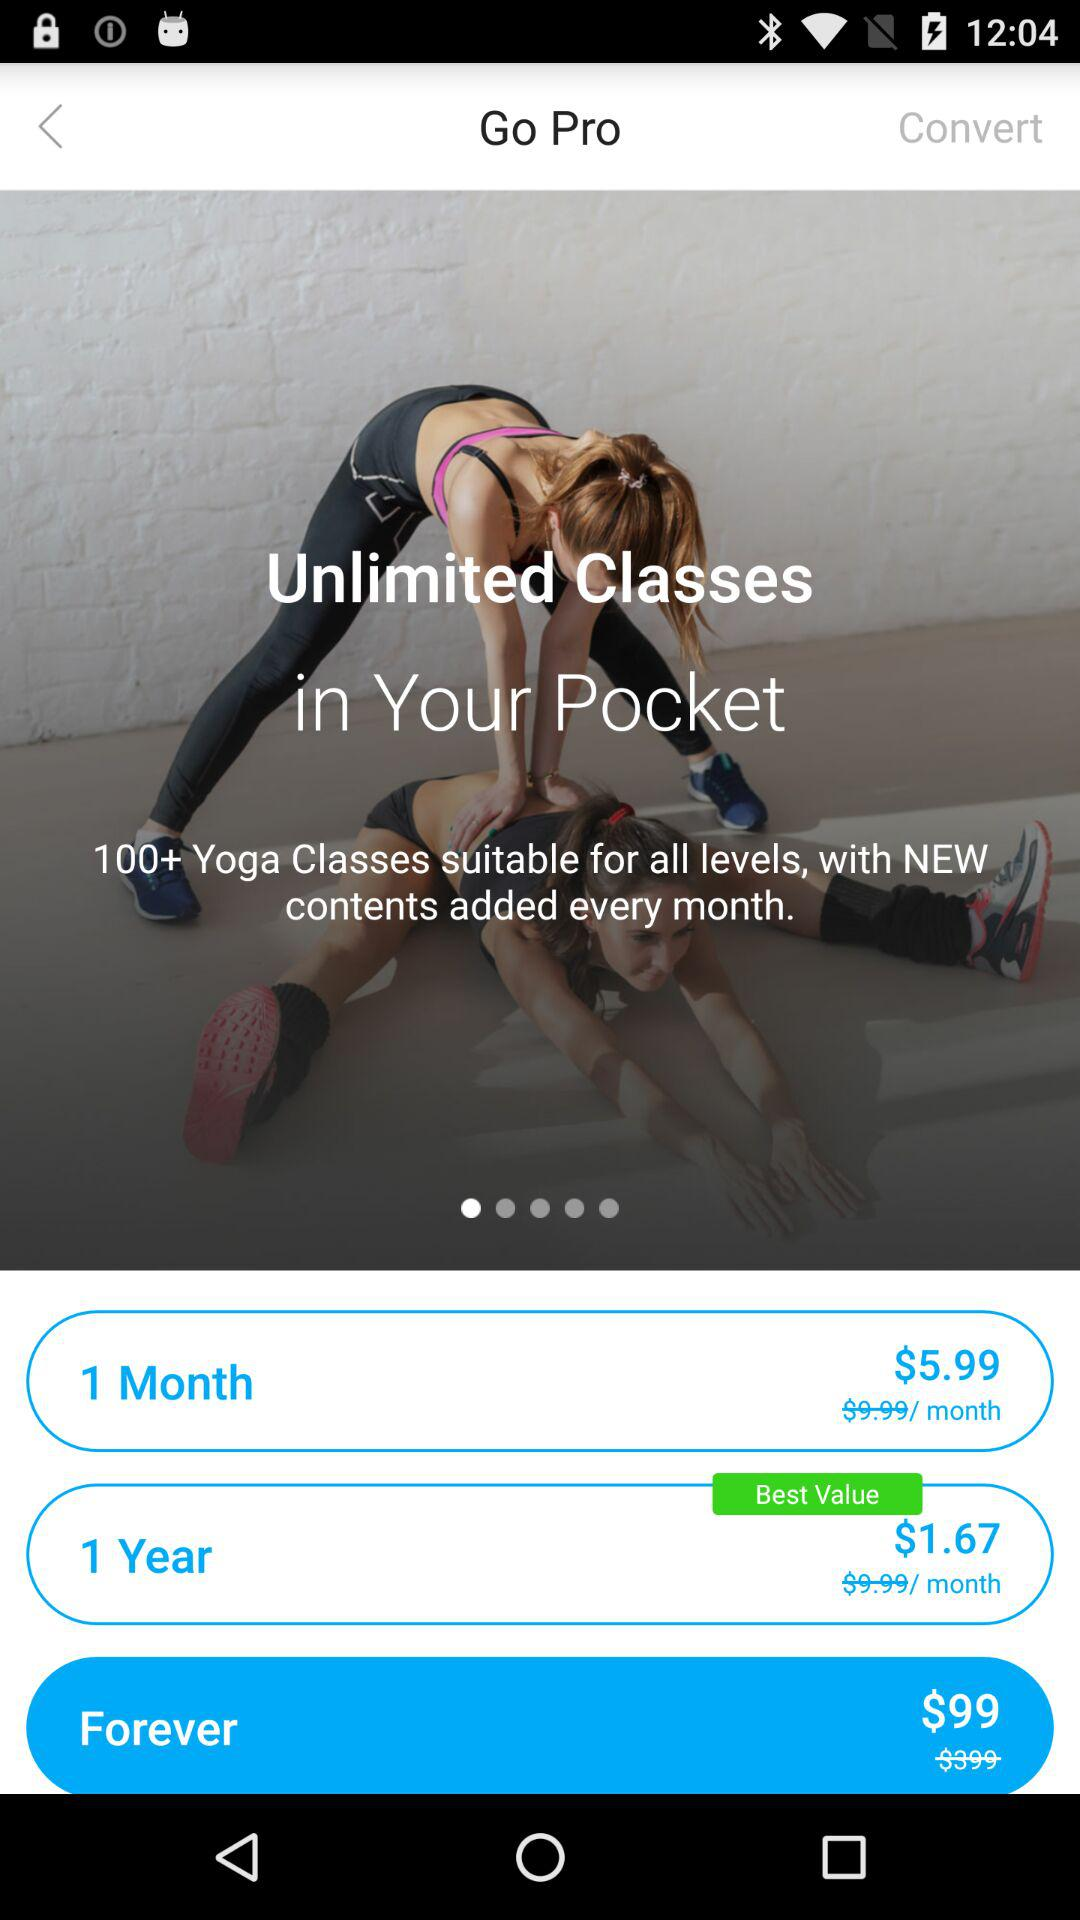What is the cost of "Forever"? The cost of "Forever" is $99. 